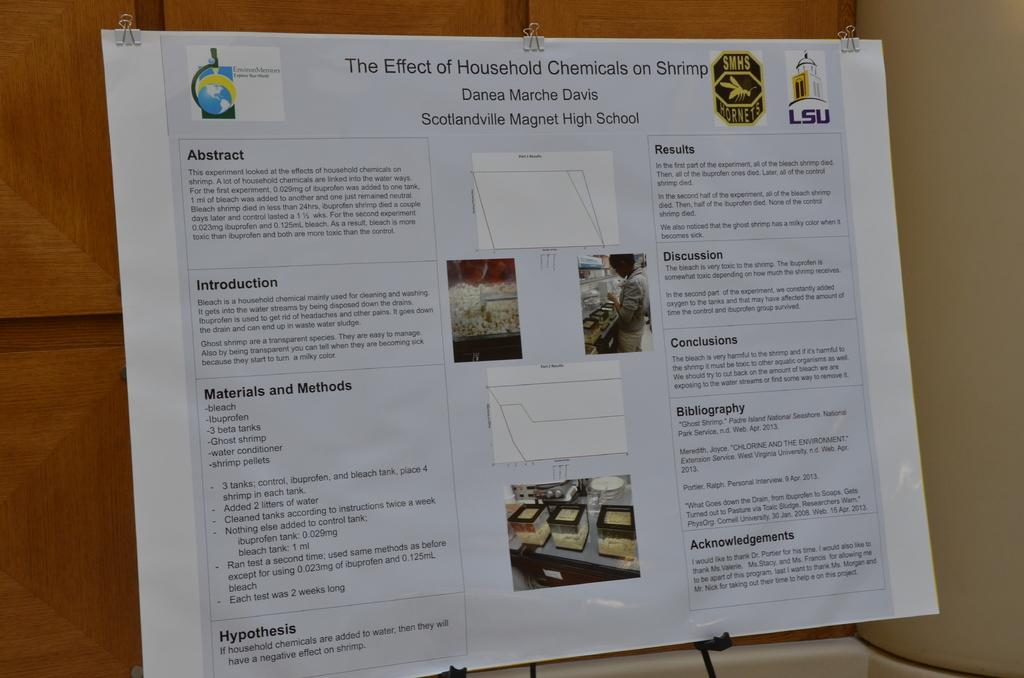<image>
Relay a brief, clear account of the picture shown. a paper with some household chemicals on it 